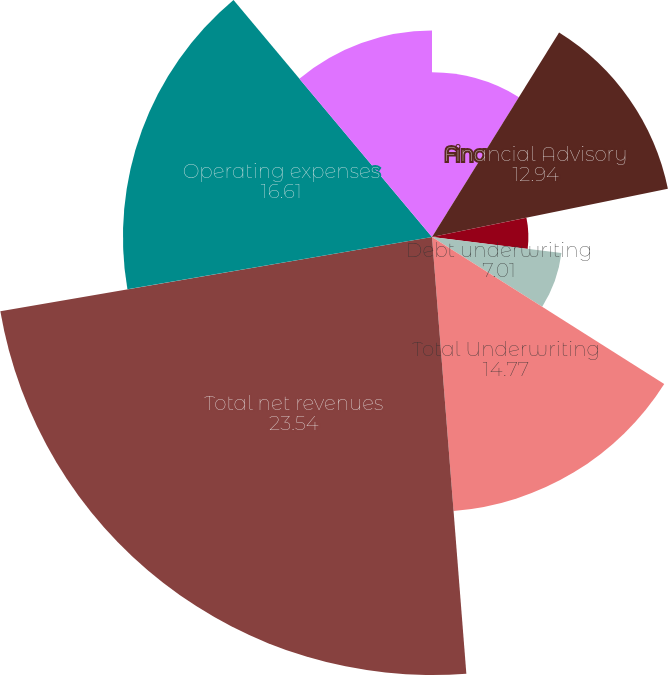Convert chart. <chart><loc_0><loc_0><loc_500><loc_500><pie_chart><fcel>in millions<fcel>Financial Advisory<fcel>Equity underwriting<fcel>Debt underwriting<fcel>Total Underwriting<fcel>Total net revenues<fcel>Operating expenses<fcel>Pre-tax earnings<nl><fcel>8.85%<fcel>12.94%<fcel>5.18%<fcel>7.01%<fcel>14.77%<fcel>23.54%<fcel>16.61%<fcel>11.1%<nl></chart> 